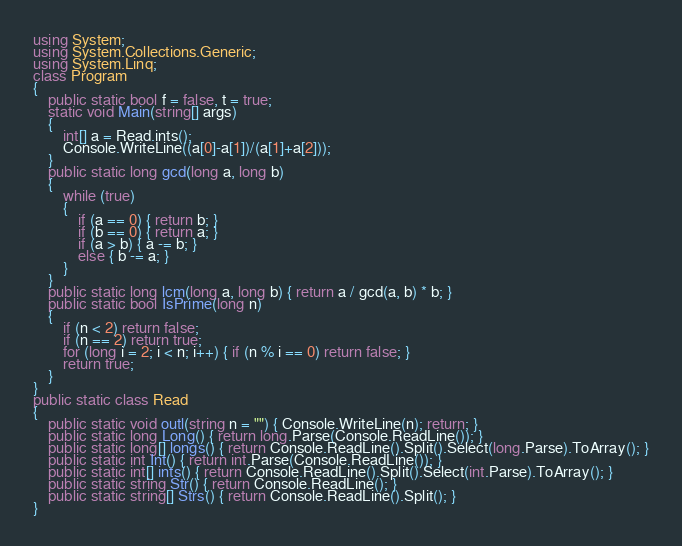<code> <loc_0><loc_0><loc_500><loc_500><_C#_>using System;
using System.Collections.Generic;
using System.Linq;
class Program
{
    public static bool f = false, t = true;
    static void Main(string[] args)
    {
        int[] a = Read.ints();
        Console.WriteLine((a[0]-a[1])/(a[1]+a[2]));
    }
    public static long gcd(long a, long b)
    {
        while (true)
        {
            if (a == 0) { return b; }
            if (b == 0) { return a; }
            if (a > b) { a -= b; }
            else { b -= a; }
        }
    }
    public static long lcm(long a, long b) { return a / gcd(a, b) * b; }
    public static bool IsPrime(long n)
    {
        if (n < 2) return false;
        if (n == 2) return true;
        for (long i = 2; i < n; i++) { if (n % i == 0) return false; }
        return true;
    }
}
public static class Read
{
    public static void outl(string n = "") { Console.WriteLine(n); return; }
    public static long Long() { return long.Parse(Console.ReadLine()); }
    public static long[] longs() { return Console.ReadLine().Split().Select(long.Parse).ToArray(); }
    public static int Int() { return int.Parse(Console.ReadLine()); }
    public static int[] ints() { return Console.ReadLine().Split().Select(int.Parse).ToArray(); }
    public static string Str() { return Console.ReadLine(); }
    public static string[] Strs() { return Console.ReadLine().Split(); }
}</code> 